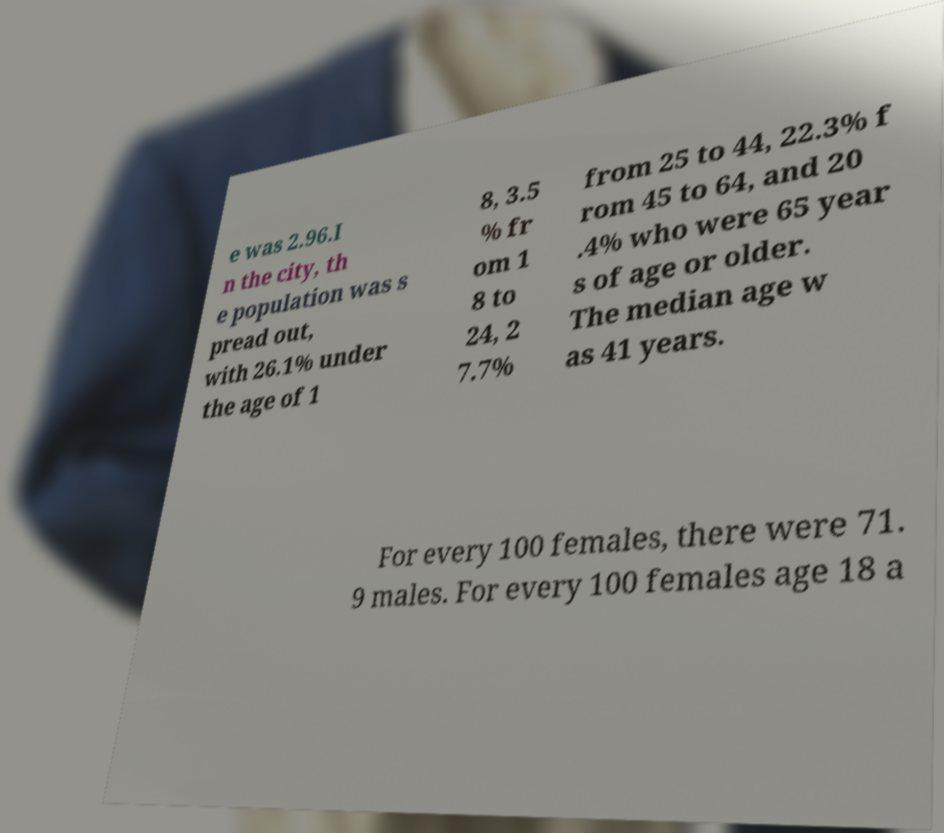For documentation purposes, I need the text within this image transcribed. Could you provide that? e was 2.96.I n the city, th e population was s pread out, with 26.1% under the age of 1 8, 3.5 % fr om 1 8 to 24, 2 7.7% from 25 to 44, 22.3% f rom 45 to 64, and 20 .4% who were 65 year s of age or older. The median age w as 41 years. For every 100 females, there were 71. 9 males. For every 100 females age 18 a 